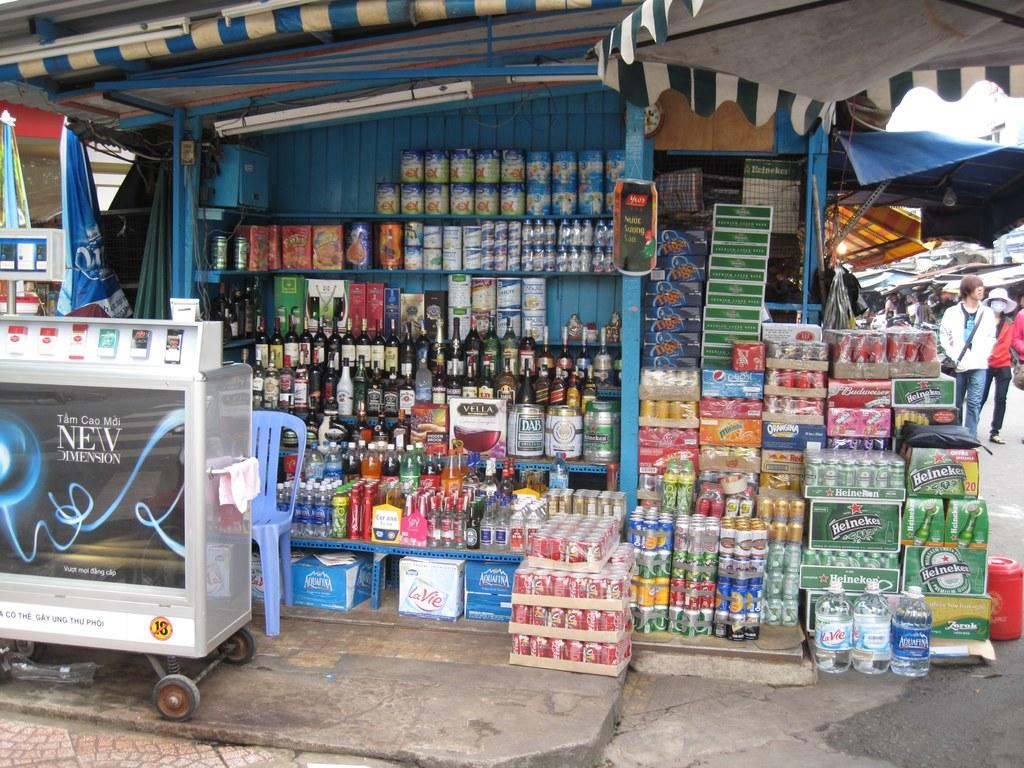Provide a one-sentence caption for the provided image. an open store front with liquor and various canned goods with an ad for NEW DIMENSION. 